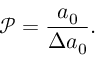Convert formula to latex. <formula><loc_0><loc_0><loc_500><loc_500>\mathcal { P } = \frac { a _ { 0 } } { \Delta a _ { 0 } } .</formula> 